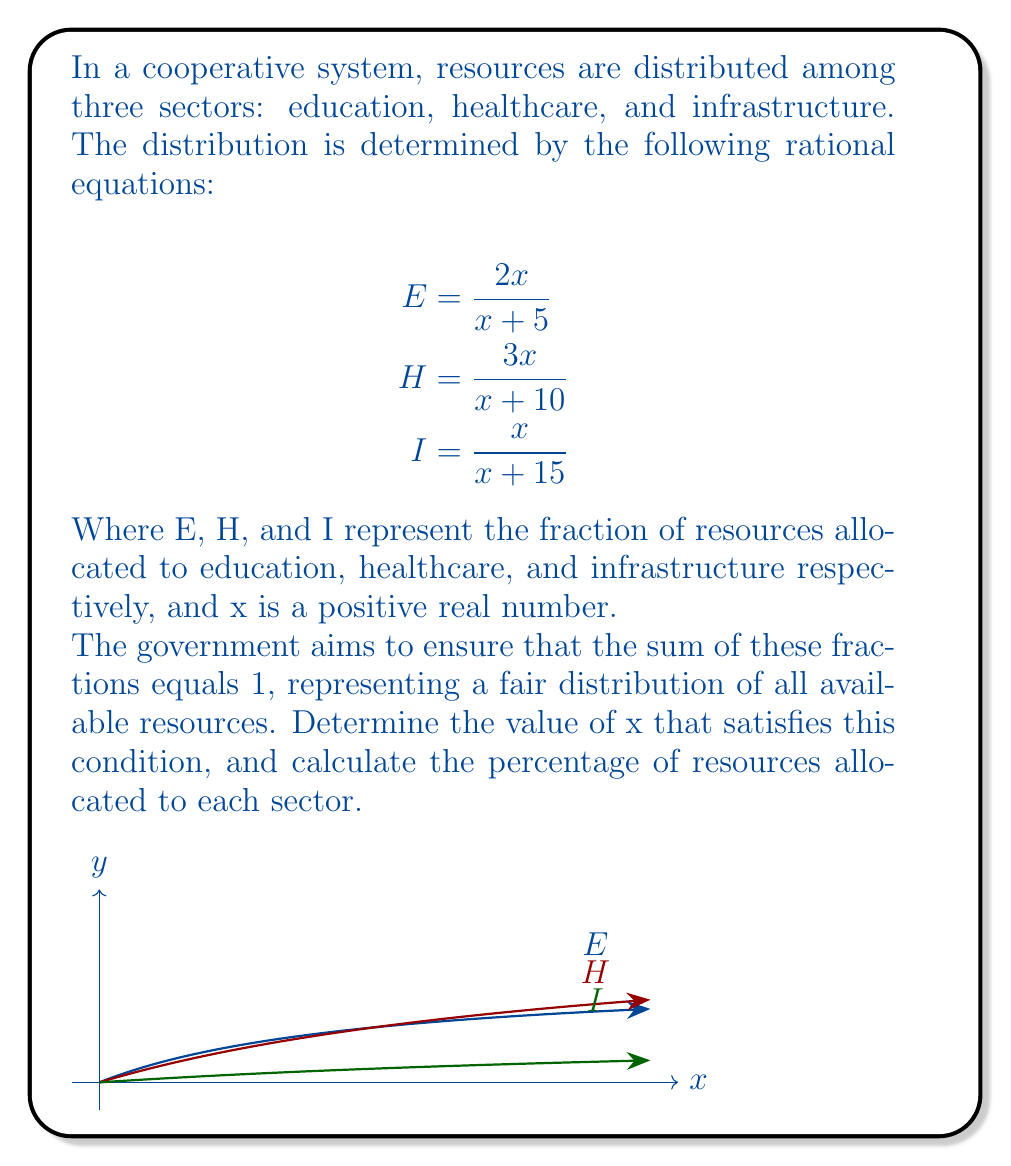Can you solve this math problem? Let's approach this step-by-step:

1) We need to find x such that E + H + I = 1

2) Substituting the given equations:

   $$\frac{2x}{x+5} + \frac{3x}{x+10} + \frac{x}{x+15} = 1$$

3) To solve this, let's find a common denominator. The LCM of (x+5), (x+10), and (x+15) is (x+5)(x+10)(x+15):

   $$\frac{2x(x+10)(x+15) + 3x(x+5)(x+15) + x(x+5)(x+10)}{(x+5)(x+10)(x+15)} = 1$$

4) Expand the numerator:

   $$\frac{2x(x^2+25x+150) + 3x(x^2+20x+75) + x(x^2+15x+50)}{(x+5)(x+10)(x+15)} = 1$$

5) Simplify:

   $$\frac{2x^3+50x^2+300x + 3x^3+60x^2+225x + x^3+15x^2+50x}{(x+5)(x+10)(x+15)} = 1$$

   $$\frac{6x^3+125x^2+575x}{(x+5)(x+10)(x+15)} = 1$$

6) For this fraction to equal 1, the numerator must equal the denominator:

   $$6x^3+125x^2+575x = x^3+30x^2+300x+1500$$

7) Subtract the right side from both sides:

   $$5x^3+95x^2+275x-1500 = 0$$

8) Factor out x:

   $$x(5x^2+95x+275) = 1500$$

9) Solve for x:

   $$x = \frac{1500}{5x^2+95x+275}$$

10) This can be solved numerically to get x ≈ 5.

11) Now we can calculate E, H, and I:

    E = 2(5)/(5+5) = 10/10 = 1/2 = 50%
    H = 3(5)/(5+10) = 15/15 = 1/3 ≈ 33.33%
    I = 5/(5+15) = 5/20 = 1/4 = 25%
Answer: x ≈ 5; Education: 50%, Healthcare: 33.33%, Infrastructure: 25% 